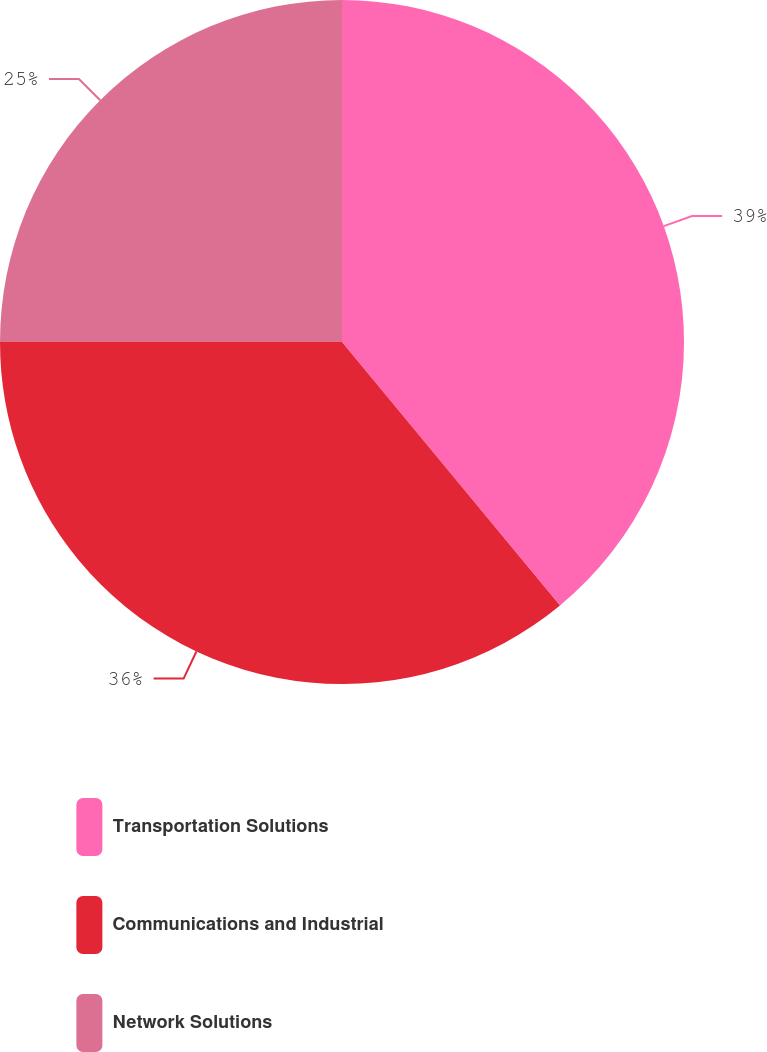Convert chart to OTSL. <chart><loc_0><loc_0><loc_500><loc_500><pie_chart><fcel>Transportation Solutions<fcel>Communications and Industrial<fcel>Network Solutions<nl><fcel>39.0%<fcel>36.0%<fcel>25.0%<nl></chart> 